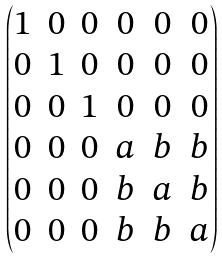Convert formula to latex. <formula><loc_0><loc_0><loc_500><loc_500>\begin{pmatrix} 1 & 0 & 0 & 0 & 0 & 0 \\ 0 & 1 & 0 & 0 & 0 & 0 \\ 0 & 0 & 1 & 0 & 0 & 0 \\ 0 & 0 & 0 & a & b & b \\ 0 & 0 & 0 & b & a & b \\ 0 & 0 & 0 & b & b & a \end{pmatrix}</formula> 